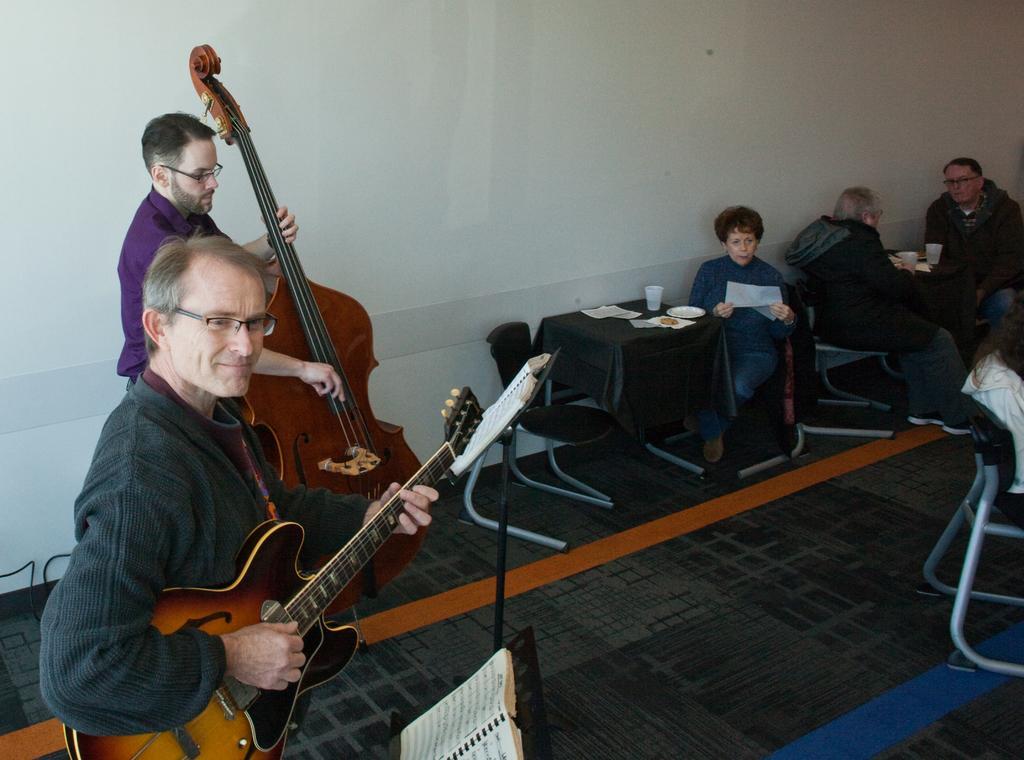How would you summarize this image in a sentence or two? In this image I can see two people standing and holding the guitar and in front of these people there are few more people sitting. 